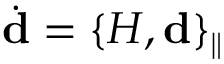<formula> <loc_0><loc_0><loc_500><loc_500>\dot { d } = \{ H , { d } \} _ { \| }</formula> 